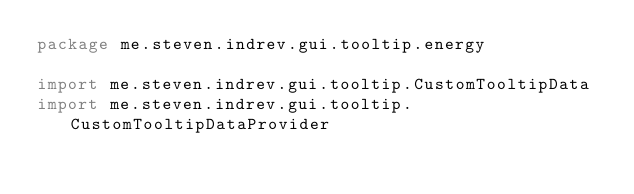<code> <loc_0><loc_0><loc_500><loc_500><_Kotlin_>package me.steven.indrev.gui.tooltip.energy

import me.steven.indrev.gui.tooltip.CustomTooltipData
import me.steven.indrev.gui.tooltip.CustomTooltipDataProvider</code> 